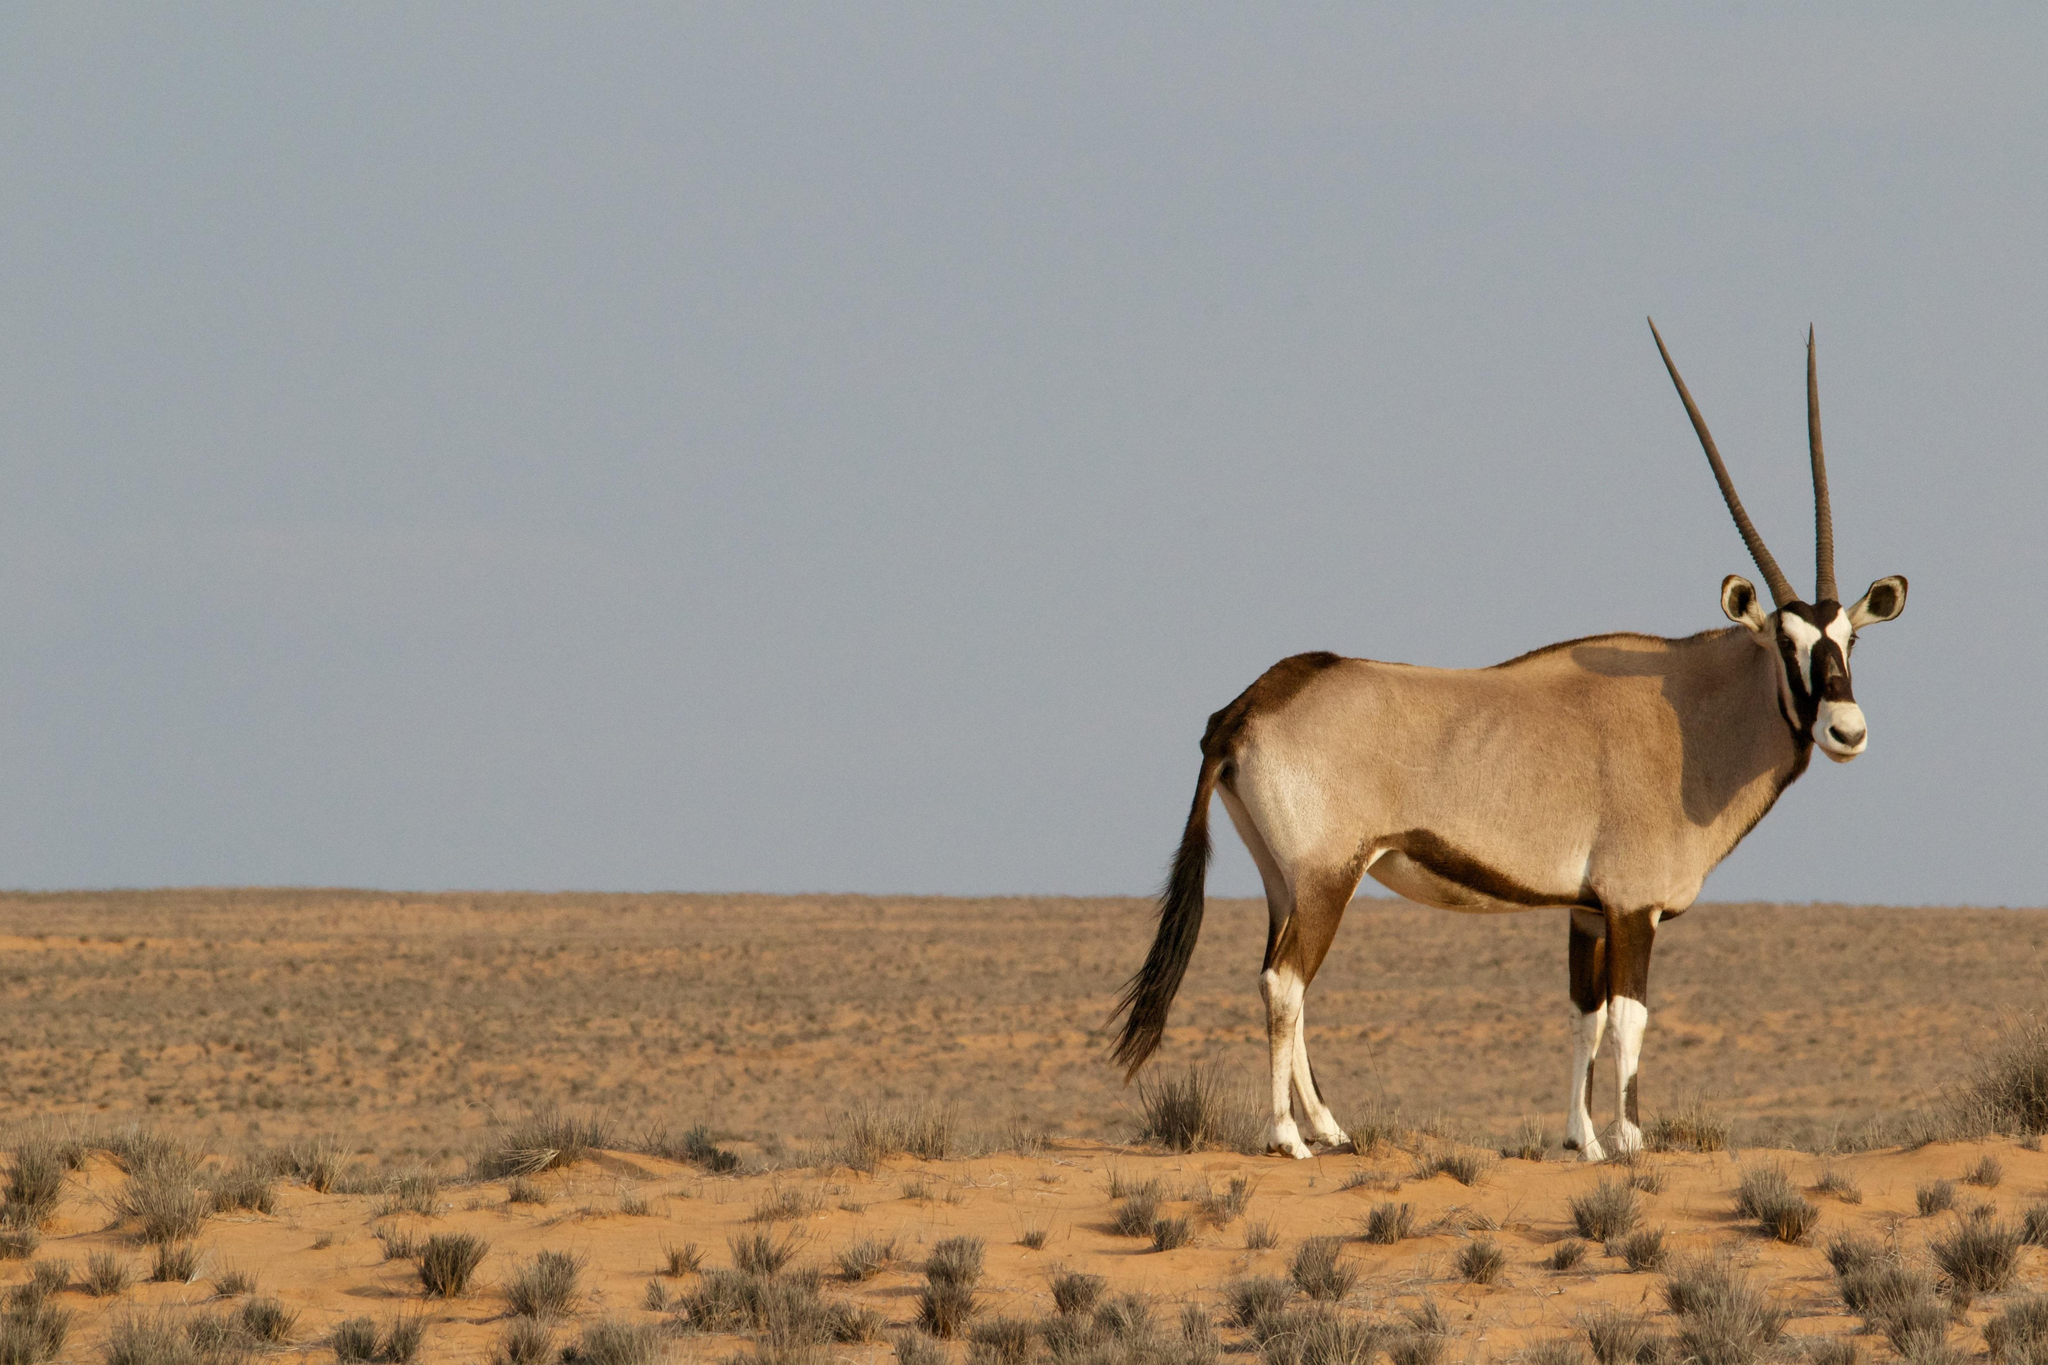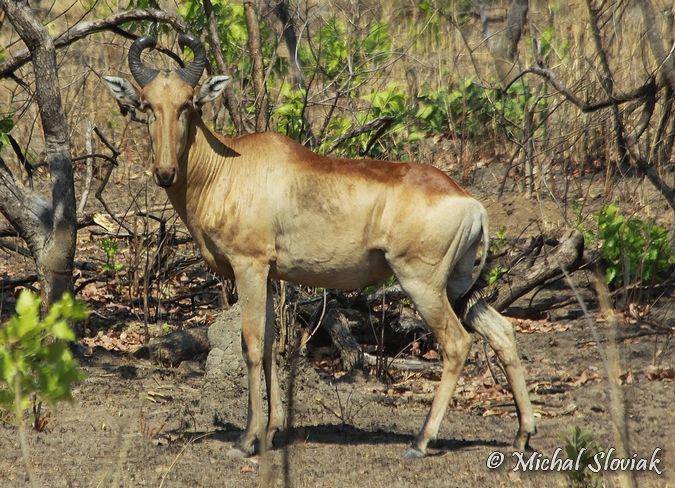The first image is the image on the left, the second image is the image on the right. Considering the images on both sides, is "The left image features more antelopes in the foreground than the right image." valid? Answer yes or no. No. 